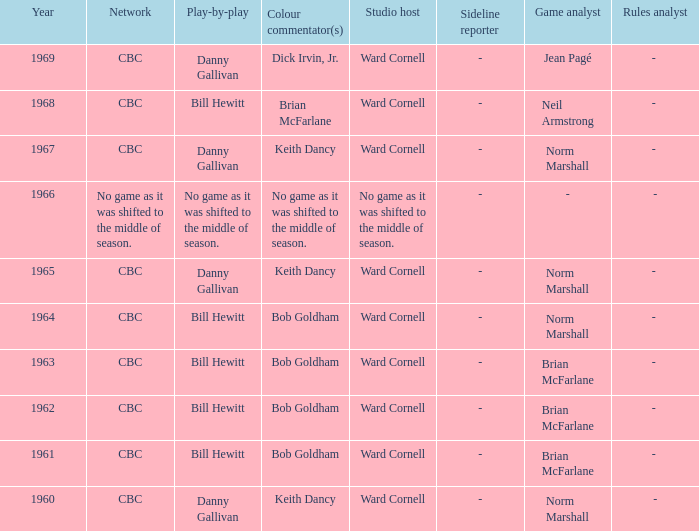Were the color commentators who worked with Bill Hewitt doing the play-by-play? Brian McFarlane, Bob Goldham, Bob Goldham, Bob Goldham, Bob Goldham. 